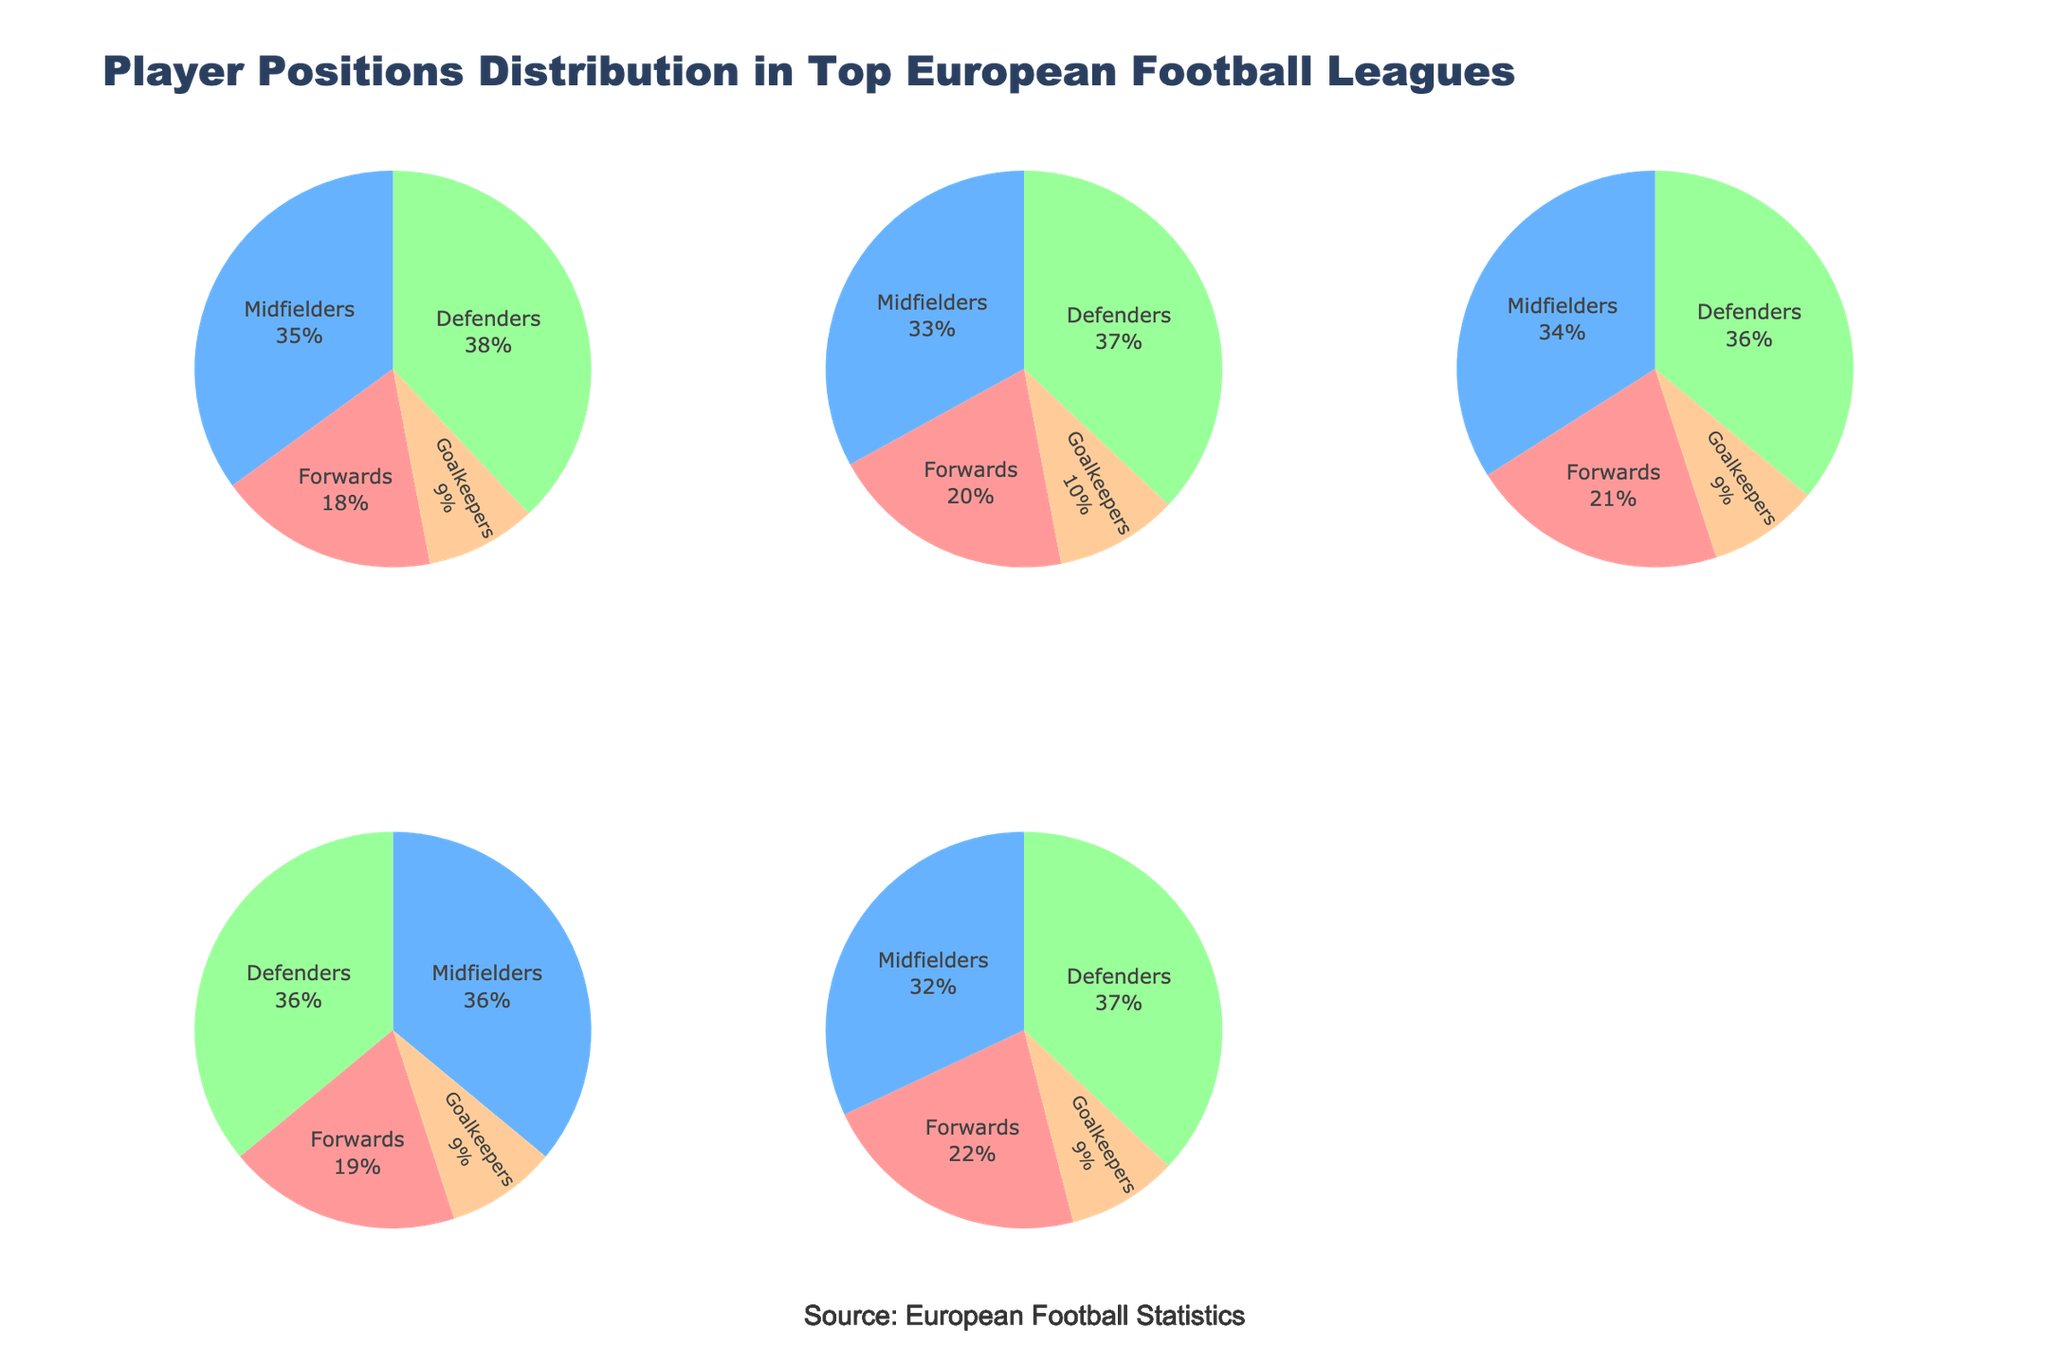What are the four positions shown in the pie charts? Each pie chart represents the distribution of players in four positions. By looking at any of the pie charts, you can see the labels: "Forwards," "Midfielders," "Defenders," and "Goalkeepers."
Answer: Forwards, Midfielders, Defenders, Goalkeepers Which league has the highest percentage of forwards? Check each pie chart to see the percentage of forwards. Ligue 1 shows the highest percentage of forwards, marked at 22%.
Answer: Ligue 1 What is the title of the figure? The title is prominently displayed at the top of the subplot figure. It reads "Player Positions Distribution in Top European Football Leagues."
Answer: Player Positions Distribution in Top European Football Leagues How does the percentage of midfielders in the Premier League compare to La Liga? Locate the pie charts for both the Premier League and La Liga. The Premier League has 35% midfielders and La Liga has 33%. Therefore, the Premier League has a slightly higher percentage of midfielders.
Answer: Premier League has 2% more midfielders than La Liga What's the total percentage of defenders in all the leagues combined? Add the percentage of defenders from each league: Premier League (38%), La Liga (37%), Bundesliga (36%), Serie A (36%), and Ligue 1 (37%). The total is 38 + 37 + 36 + 36 + 37 = 184%.
Answer: 184% Which two leagues have the same percentage of goalkeepers? Look at the pie charts and compare the percentages of goalkeepers. The Premier League, Bundesliga, Serie A, and Ligue 1 all have 9% goalkeepers. The La Liga has 10% goalkeepers. Thus, the Premier League, Bundesliga, Serie A, and Ligue 1 have the same percentage of goalkeepers.
Answer: Premier League, Bundesliga, Serie A, Ligue 1 What's the difference in the percentage of forwards between Bundesliga and Serie A? Check the pie charts for Bundesliga and Serie A. Bundesliga has 21% forwards while Serie A has 19%. The difference is 21% - 19% = 2%.
Answer: 2% Which league has the most balanced distribution of player positions? Determine the balance by observing how close the percentages are for each position within a league. Serie A has very balanced percentages: Forwards (19%), Midfielders (36%), Defenders (36%), and Goalkeepers (9%).
Answer: Serie A 